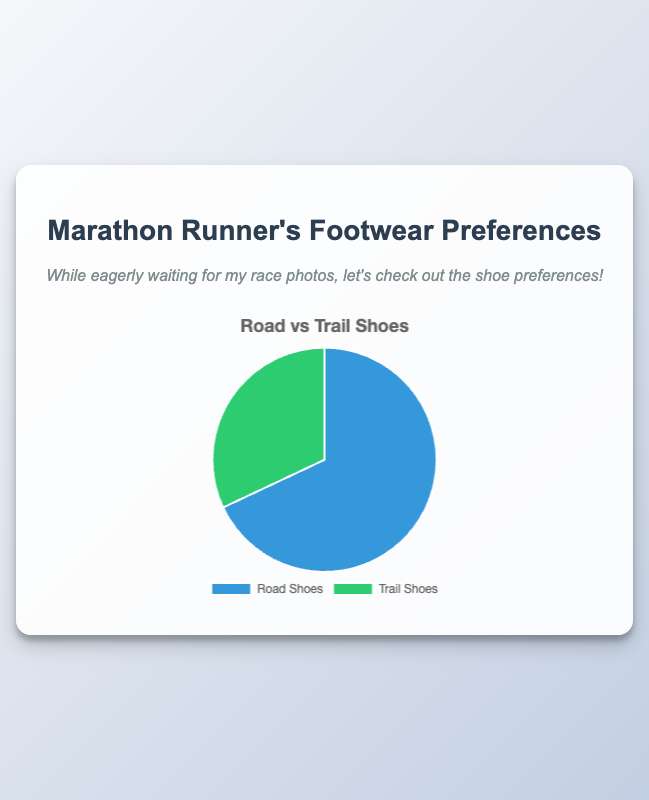What percentage of marathon runners prefer road shoes? The pie chart provides data on preferences, and 68% of marathon runners prefer road shoes.
Answer: 68% What is the percentage difference between road shoes and trail shoes? The pie chart shows 68% for road shoes and 32% for trail shoes. The percentage difference is 68% - 32% = 36%.
Answer: 36% Which type of shoes are more popular among marathon runners? By comparing the percentages, road shoes have 68%, and trail shoes have 32%. Therefore, road shoes are more popular.
Answer: Road shoes How many more marathon runners prefer road shoes over trail shoes in terms of percentage? The percentage difference is calculated by subtracting the trail shoes' percentage from the road shoes' percentage: 68% - 32% = 36%.
Answer: 36% What is the total percentage of marathon runners that prefer either Nike's Air Zoom Pegasus or Salomon's Speedcross? Nike's Air Zoom Pegasus accounts for 34%, and Salomon's Speedcross for 16%, summing to 34% + 16% = 50%.
Answer: 50% What brand and model account for the highest preference among trail shoes? Salomon's Speedcross model accounts for 16% of preferences, which is the highest among trail shoes.
Answer: Salomon Speedcross If a marathon runner does not prefer road shoes, what type of shoes would they prefer? The pie chart indicates that if a runner doesn't prefer road shoes (68%), they would prefer trail shoes (32%).
Answer: Trail shoes Is the proportion of runners who prefer Hoka One One's Clifton or Brooks' Adrenaline GTS higher than those who prefer La Sportiva's Bushido II? Hoka One One's Clifton (12%) + Brooks' Adrenaline GTS (22%) = 34%, which is higher than La Sportiva's Bushido II (10%).
Answer: Yes How does the preference for Nike's Air Zoom Pegasus compare with Altra's Lone Peak? Nike's Air Zoom Pegasus is preferred by 34% of runners, while Altra's Lone Peak is preferred by 6%. Nike's model is more popular.
Answer: Nike's Air Zoom Pegasus What trail shoe brand is preferred by 10% of the runners? The detailed data indicates that La Sportiva's Bushido II is preferred by 10% of the runners.
Answer: La Sportiva 